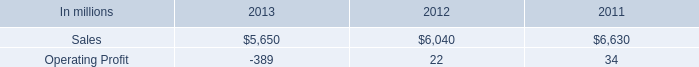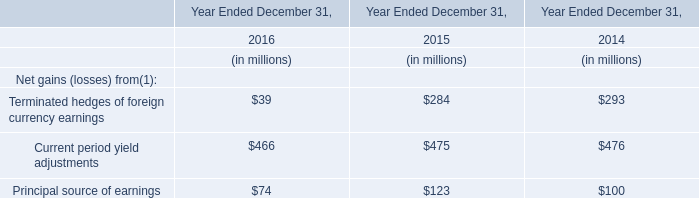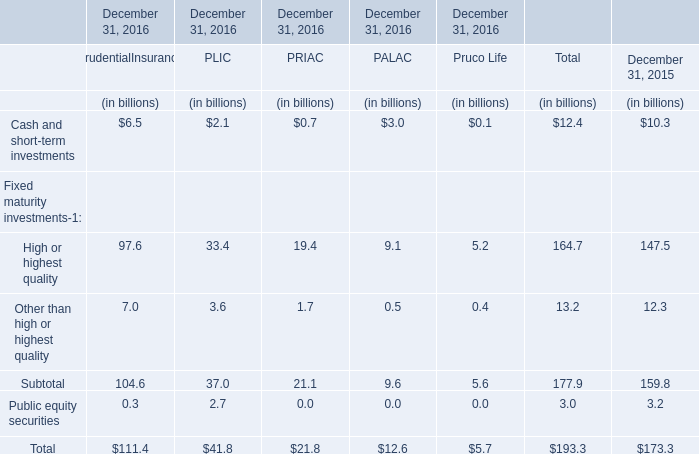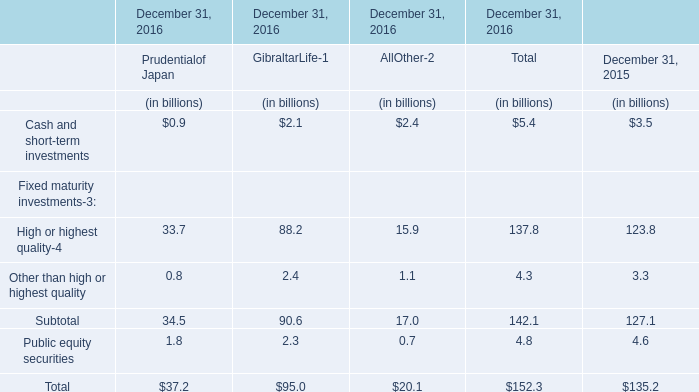At December 31, 2016,what is the value of the Public equity securities for PLIC ? (in billion) 
Answer: 2.7. 